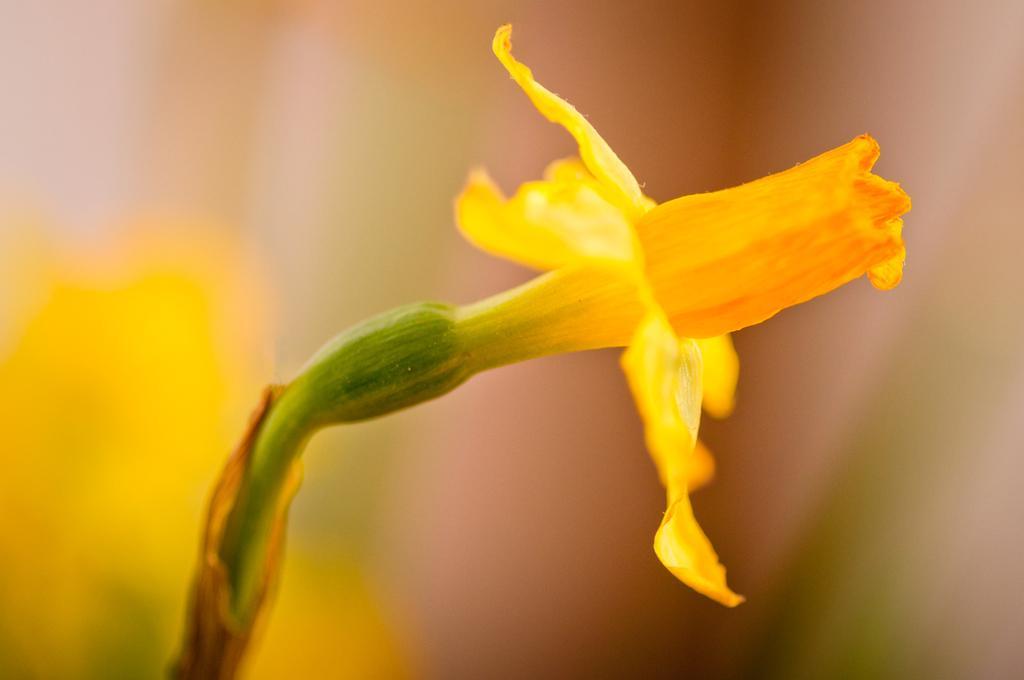Can you describe this image briefly? In this image I can see the flower to the plant. The flower is in yellow color and there is a blurred background. 